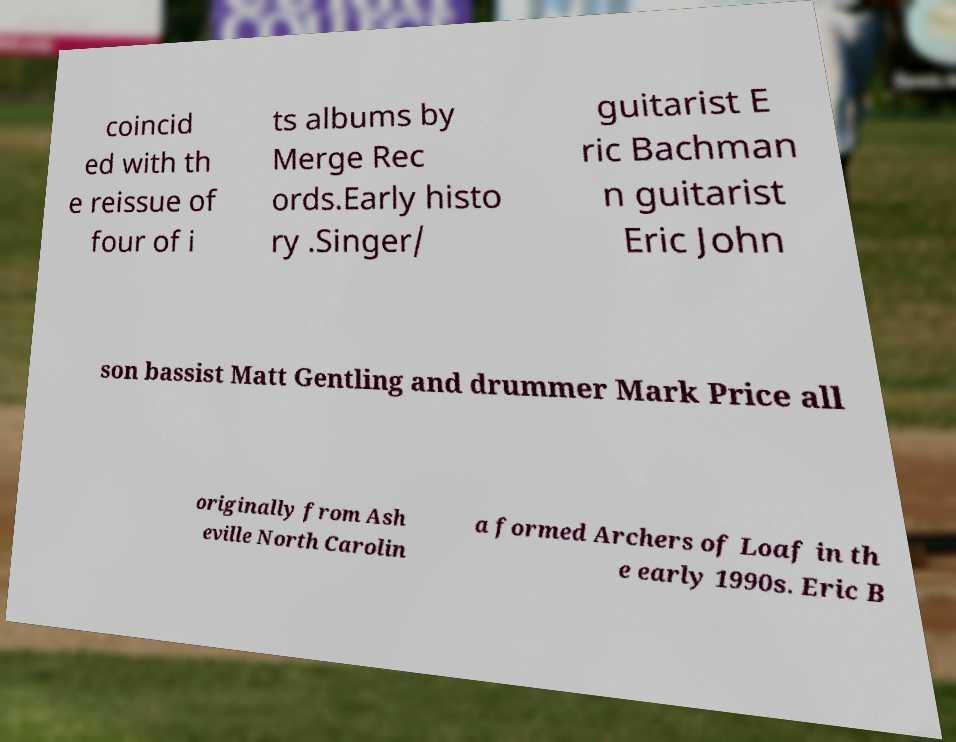Could you extract and type out the text from this image? coincid ed with th e reissue of four of i ts albums by Merge Rec ords.Early histo ry .Singer/ guitarist E ric Bachman n guitarist Eric John son bassist Matt Gentling and drummer Mark Price all originally from Ash eville North Carolin a formed Archers of Loaf in th e early 1990s. Eric B 